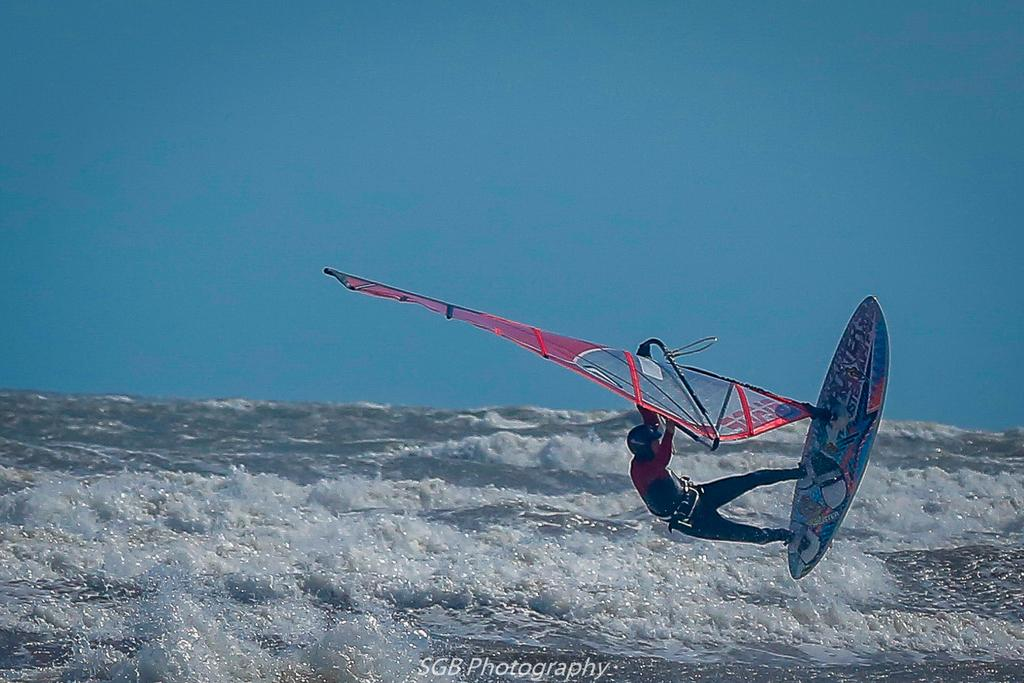What is happening in the image? There is a person in the image who is surfing on the water. Can you describe the activity the person is engaged in? The person is surfing, which involves riding a surfboard on the water. Where is the volleyball court located in the image? There is no volleyball court present in the image; it features a person surfing on the water. What type of root can be seen growing near the person in the image? There are no roots visible in the image, as it features a person surfing on the water. 